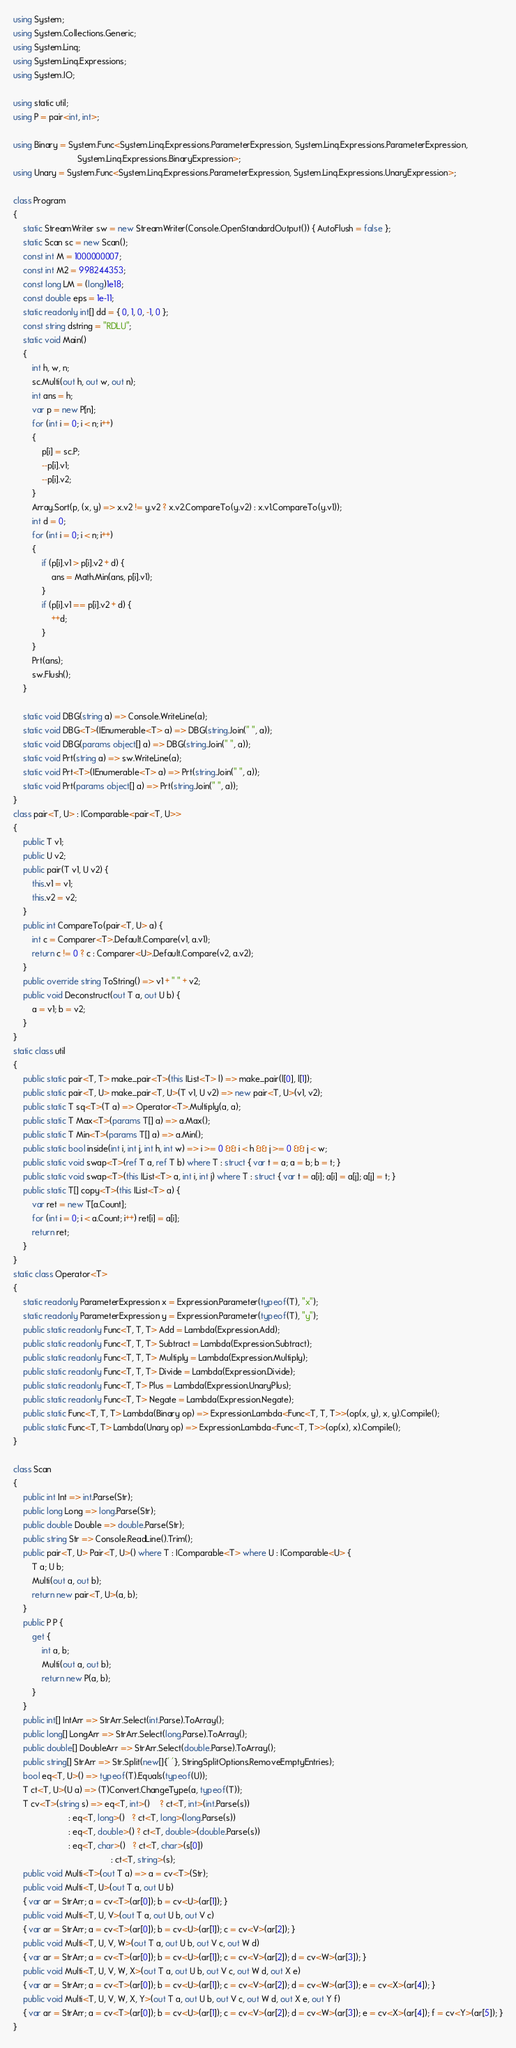<code> <loc_0><loc_0><loc_500><loc_500><_C#_>using System;
using System.Collections.Generic;
using System.Linq;
using System.Linq.Expressions;
using System.IO;

using static util;
using P = pair<int, int>;

using Binary = System.Func<System.Linq.Expressions.ParameterExpression, System.Linq.Expressions.ParameterExpression,
                           System.Linq.Expressions.BinaryExpression>;
using Unary = System.Func<System.Linq.Expressions.ParameterExpression, System.Linq.Expressions.UnaryExpression>;

class Program
{
    static StreamWriter sw = new StreamWriter(Console.OpenStandardOutput()) { AutoFlush = false };
    static Scan sc = new Scan();
    const int M = 1000000007;
    const int M2 = 998244353;
    const long LM = (long)1e18;
    const double eps = 1e-11;
    static readonly int[] dd = { 0, 1, 0, -1, 0 };
    const string dstring = "RDLU";
    static void Main()
    {
        int h, w, n;
        sc.Multi(out h, out w, out n);
        int ans = h;
        var p = new P[n];
        for (int i = 0; i < n; i++)
        {
            p[i] = sc.P;
            --p[i].v1;
            --p[i].v2;
        }
        Array.Sort(p, (x, y) => x.v2 != y.v2 ? x.v2.CompareTo(y.v2) : x.v1.CompareTo(y.v1));
        int d = 0;
        for (int i = 0; i < n; i++)
        {
            if (p[i].v1 > p[i].v2 + d) {
                ans = Math.Min(ans, p[i].v1);
            }
            if (p[i].v1 == p[i].v2 + d) {
                ++d;
            }
        }
        Prt(ans);
        sw.Flush();
    }

    static void DBG(string a) => Console.WriteLine(a);
    static void DBG<T>(IEnumerable<T> a) => DBG(string.Join(" ", a));
    static void DBG(params object[] a) => DBG(string.Join(" ", a));
    static void Prt(string a) => sw.WriteLine(a);
    static void Prt<T>(IEnumerable<T> a) => Prt(string.Join(" ", a));
    static void Prt(params object[] a) => Prt(string.Join(" ", a));
}
class pair<T, U> : IComparable<pair<T, U>>
{
    public T v1;
    public U v2;
    public pair(T v1, U v2) {
        this.v1 = v1;
        this.v2 = v2;
    }
    public int CompareTo(pair<T, U> a) {
        int c = Comparer<T>.Default.Compare(v1, a.v1);
        return c != 0 ? c : Comparer<U>.Default.Compare(v2, a.v2);
    }
    public override string ToString() => v1 + " " + v2;
    public void Deconstruct(out T a, out U b) {
        a = v1; b = v2;
    }
}
static class util
{
    public static pair<T, T> make_pair<T>(this IList<T> l) => make_pair(l[0], l[1]);
    public static pair<T, U> make_pair<T, U>(T v1, U v2) => new pair<T, U>(v1, v2);
    public static T sq<T>(T a) => Operator<T>.Multiply(a, a);
    public static T Max<T>(params T[] a) => a.Max();
    public static T Min<T>(params T[] a) => a.Min();
    public static bool inside(int i, int j, int h, int w) => i >= 0 && i < h && j >= 0 && j < w;
    public static void swap<T>(ref T a, ref T b) where T : struct { var t = a; a = b; b = t; }
    public static void swap<T>(this IList<T> a, int i, int j) where T : struct { var t = a[i]; a[i] = a[j]; a[j] = t; }
    public static T[] copy<T>(this IList<T> a) {
        var ret = new T[a.Count];
        for (int i = 0; i < a.Count; i++) ret[i] = a[i];
        return ret;
    }
}
static class Operator<T>
{
    static readonly ParameterExpression x = Expression.Parameter(typeof(T), "x");
    static readonly ParameterExpression y = Expression.Parameter(typeof(T), "y");
    public static readonly Func<T, T, T> Add = Lambda(Expression.Add);
    public static readonly Func<T, T, T> Subtract = Lambda(Expression.Subtract);
    public static readonly Func<T, T, T> Multiply = Lambda(Expression.Multiply);
    public static readonly Func<T, T, T> Divide = Lambda(Expression.Divide);
    public static readonly Func<T, T> Plus = Lambda(Expression.UnaryPlus);
    public static readonly Func<T, T> Negate = Lambda(Expression.Negate);
    public static Func<T, T, T> Lambda(Binary op) => Expression.Lambda<Func<T, T, T>>(op(x, y), x, y).Compile();
    public static Func<T, T> Lambda(Unary op) => Expression.Lambda<Func<T, T>>(op(x), x).Compile();
}

class Scan
{
    public int Int => int.Parse(Str);
    public long Long => long.Parse(Str);
    public double Double => double.Parse(Str);
    public string Str => Console.ReadLine().Trim();
    public pair<T, U> Pair<T, U>() where T : IComparable<T> where U : IComparable<U> {
        T a; U b;
        Multi(out a, out b);
        return new pair<T, U>(a, b);
    }
    public P P {
        get {
            int a, b;
            Multi(out a, out b);
            return new P(a, b);
        }
    }
    public int[] IntArr => StrArr.Select(int.Parse).ToArray();
    public long[] LongArr => StrArr.Select(long.Parse).ToArray();
    public double[] DoubleArr => StrArr.Select(double.Parse).ToArray();
    public string[] StrArr => Str.Split(new[]{' '}, StringSplitOptions.RemoveEmptyEntries);
    bool eq<T, U>() => typeof(T).Equals(typeof(U));
    T ct<T, U>(U a) => (T)Convert.ChangeType(a, typeof(T));
    T cv<T>(string s) => eq<T, int>()    ? ct<T, int>(int.Parse(s))
                       : eq<T, long>()   ? ct<T, long>(long.Parse(s))
                       : eq<T, double>() ? ct<T, double>(double.Parse(s))
                       : eq<T, char>()   ? ct<T, char>(s[0])
                                         : ct<T, string>(s);
    public void Multi<T>(out T a) => a = cv<T>(Str);
    public void Multi<T, U>(out T a, out U b)
    { var ar = StrArr; a = cv<T>(ar[0]); b = cv<U>(ar[1]); }
    public void Multi<T, U, V>(out T a, out U b, out V c)
    { var ar = StrArr; a = cv<T>(ar[0]); b = cv<U>(ar[1]); c = cv<V>(ar[2]); }
    public void Multi<T, U, V, W>(out T a, out U b, out V c, out W d)
    { var ar = StrArr; a = cv<T>(ar[0]); b = cv<U>(ar[1]); c = cv<V>(ar[2]); d = cv<W>(ar[3]); }
    public void Multi<T, U, V, W, X>(out T a, out U b, out V c, out W d, out X e)
    { var ar = StrArr; a = cv<T>(ar[0]); b = cv<U>(ar[1]); c = cv<V>(ar[2]); d = cv<W>(ar[3]); e = cv<X>(ar[4]); }
    public void Multi<T, U, V, W, X, Y>(out T a, out U b, out V c, out W d, out X e, out Y f)
    { var ar = StrArr; a = cv<T>(ar[0]); b = cv<U>(ar[1]); c = cv<V>(ar[2]); d = cv<W>(ar[3]); e = cv<X>(ar[4]); f = cv<Y>(ar[5]); }
}
</code> 